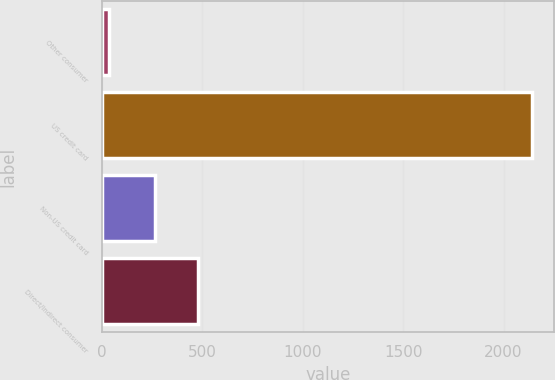<chart> <loc_0><loc_0><loc_500><loc_500><bar_chart><fcel>Other consumer<fcel>US credit card<fcel>Non-US credit card<fcel>Direct/Indirect consumer<nl><fcel>34<fcel>2144<fcel>266<fcel>477<nl></chart> 